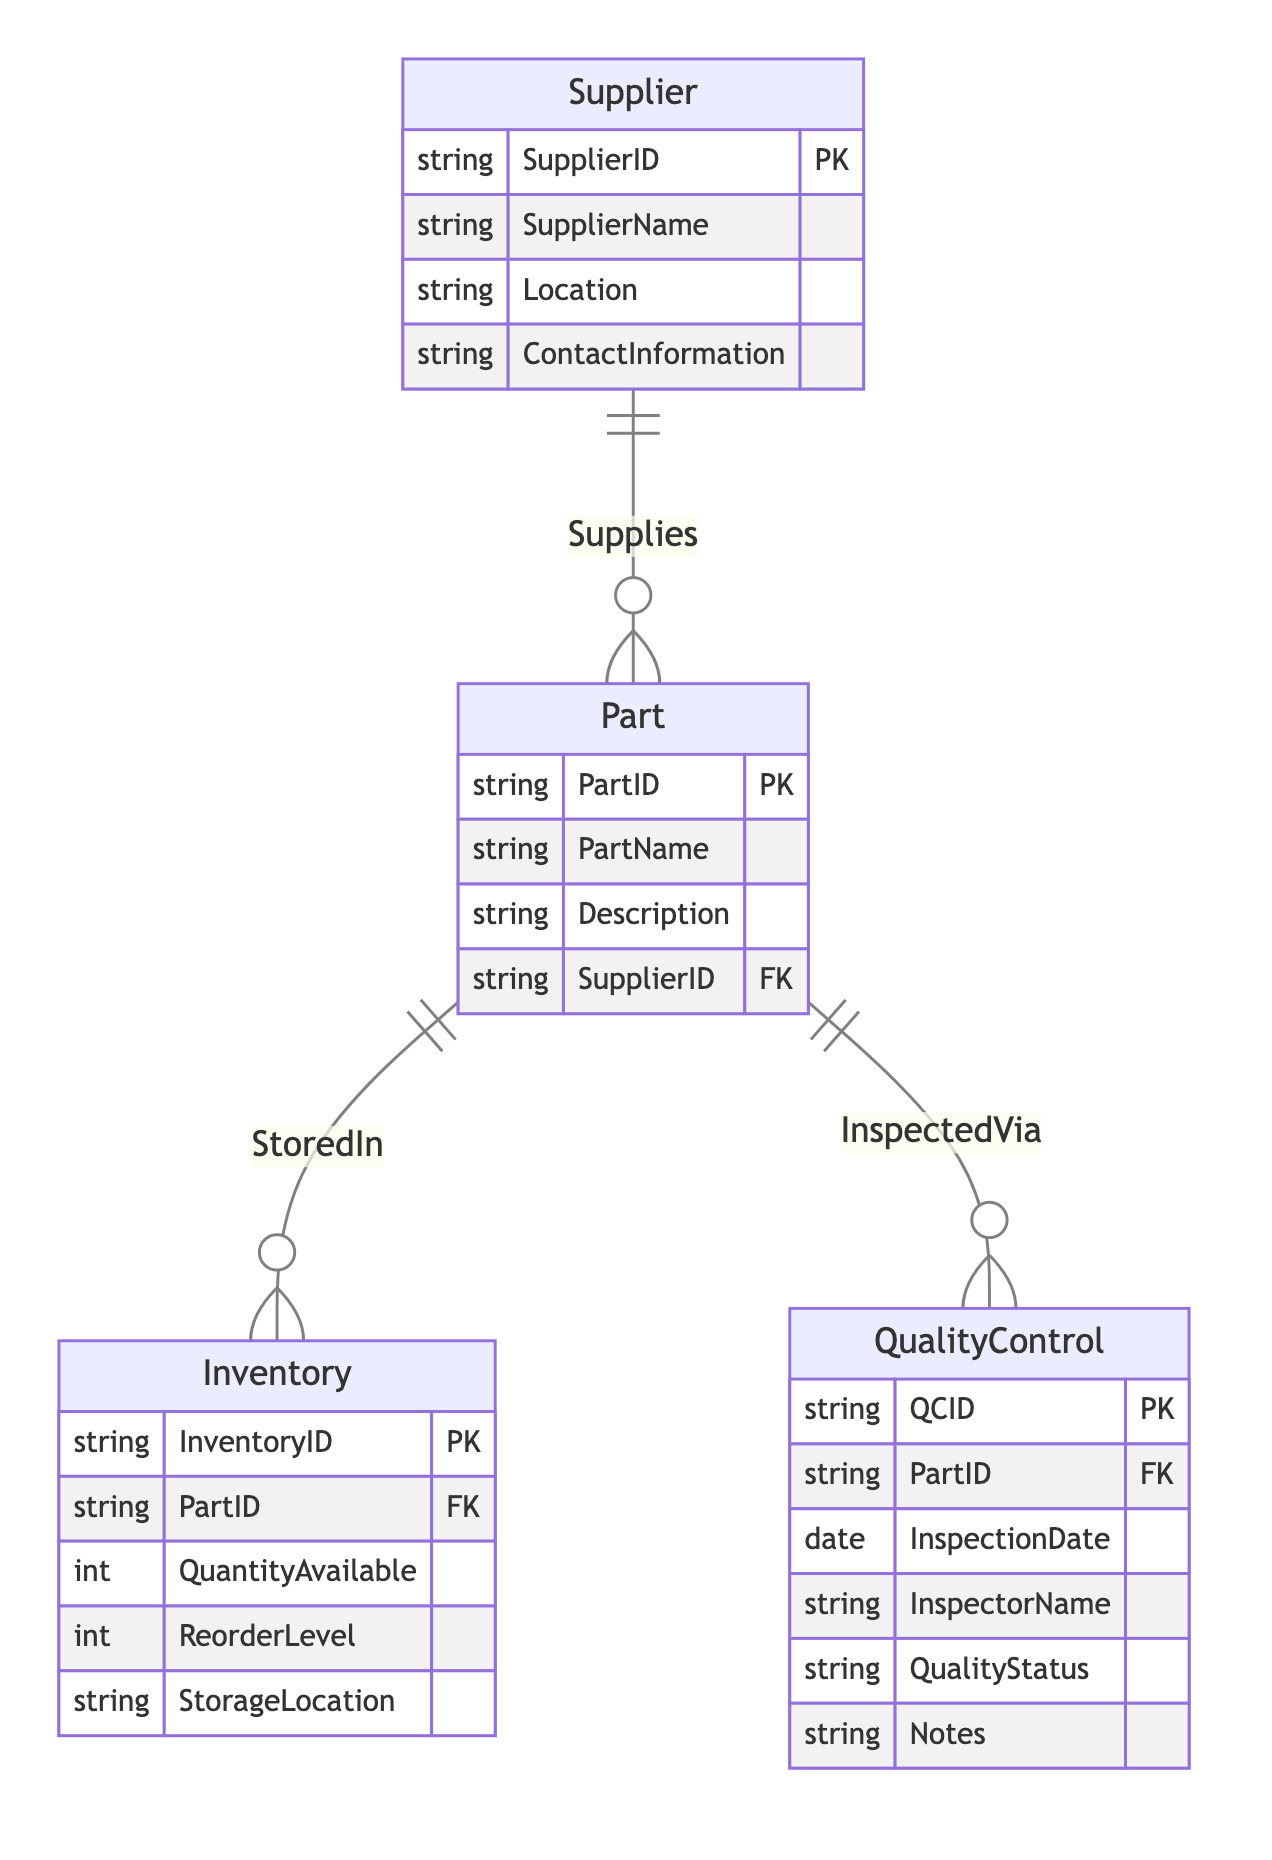What is the primary key of the Supplier entity? The primary key for the Supplier entity is SupplierID, as it's indicated in the diagram with the notation PK next to it.
Answer: SupplierID How many entities are there in the diagram? The diagram includes four entities: Supplier, Part, Inventory, and QualityControl. Counting them gives a total of four.
Answer: Four Which entity has a direct relationship with both Inventory and QualityControl? The Part entity is the common entity that has direct relationships with both Inventory and QualityControl, as shown by the lines connecting them in the diagram.
Answer: Part What is the relationship type between Supplier and Part? The relationship type between Supplier and Part is represented as "Supplies", indicating that Suppliers provide Parts. This is depicted by the line connecting the two entities in the diagram.
Answer: Supplies How many attributes does the QualityControl entity have? The QualityControl entity has six attributes: QCID, PartID, InspectionDate, InspectorName, QualityStatus, and Notes. By counting these listed attributes, we arrive at the total.
Answer: Six What is the foreign key in the Inventory entity? The foreign key in the Inventory entity is PartID, as indicated in the attributes listed for Inventory, showing how it relates to the Part entity.
Answer: PartID What is the storage location attribute in the Inventory entity? The storage location attribute in the Inventory entity is described as StorageLocation, which is one of the attributes and indicates where the Part is stored.
Answer: StorageLocation Which entity contains information about the inspection of parts? The entity that contains information about the inspection of parts is QualityControl. This entity includes details such as InspectionDate and QualityStatus, directly related to parts being inspected.
Answer: QualityControl How is quality status represented in the diagram? Quality status is represented by the attribute QualityStatus within the QualityControl entity, which provides insights into the results of inspections carried out on the Parts.
Answer: QualityStatus 